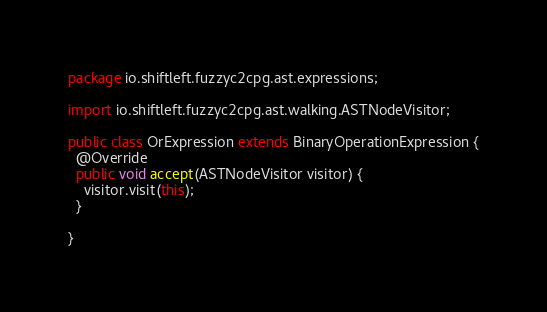<code> <loc_0><loc_0><loc_500><loc_500><_Java_>package io.shiftleft.fuzzyc2cpg.ast.expressions;

import io.shiftleft.fuzzyc2cpg.ast.walking.ASTNodeVisitor;

public class OrExpression extends BinaryOperationExpression {
  @Override
  public void accept(ASTNodeVisitor visitor) {
    visitor.visit(this);
  }

}
</code> 